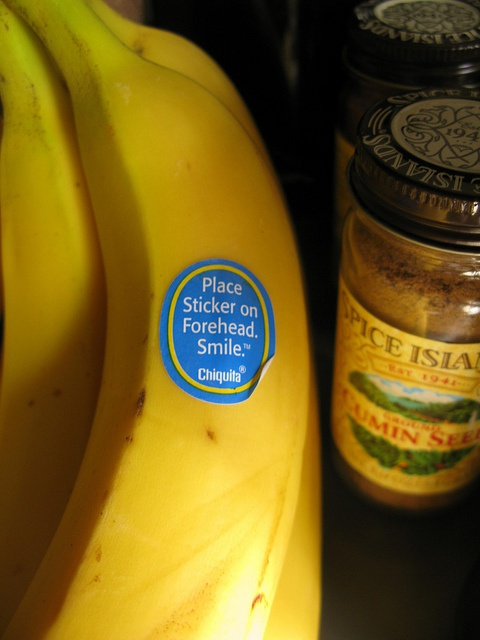Describe the objects in this image and their specific colors. I can see banana in olive, maroon, and gold tones and bottle in olive, black, and maroon tones in this image. 